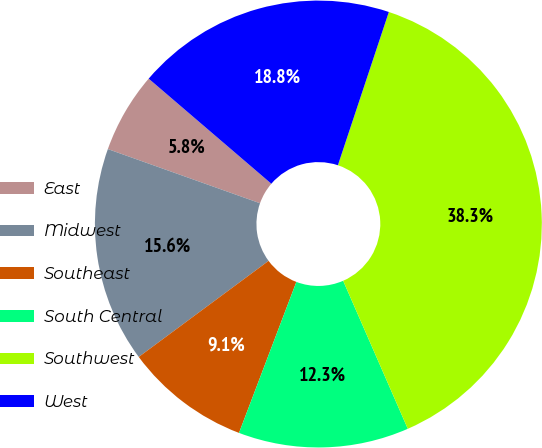Convert chart to OTSL. <chart><loc_0><loc_0><loc_500><loc_500><pie_chart><fcel>East<fcel>Midwest<fcel>Southeast<fcel>South Central<fcel>Southwest<fcel>West<nl><fcel>5.83%<fcel>15.58%<fcel>9.08%<fcel>12.33%<fcel>38.33%<fcel>18.83%<nl></chart> 